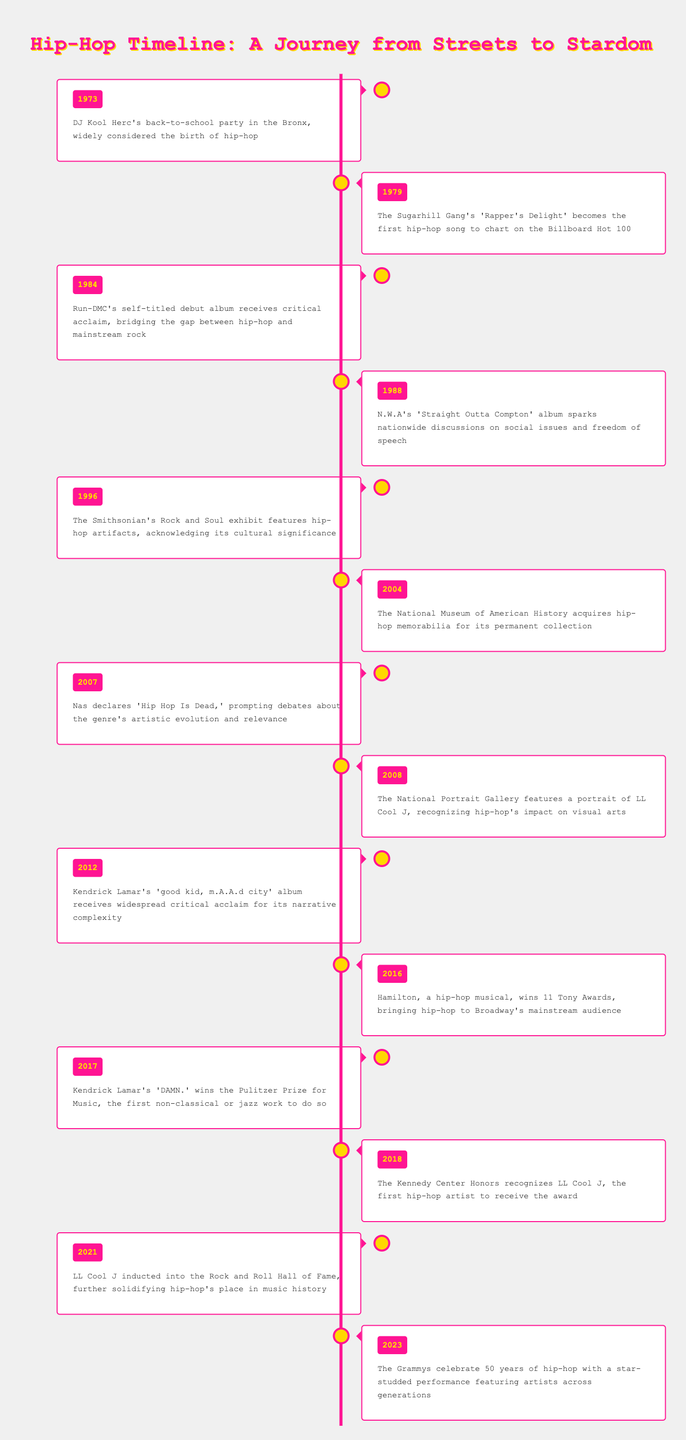What year is widely considered the birth of hip-hop? The table states that DJ Kool Herc's back-to-school party in the Bronx in 1973 is widely considered the birth of hip-hop.
Answer: 1973 Which hip-hop song first charted on the Billboard Hot 100? According to the table, The Sugarhill Gang's 'Rapper's Delight' in 1979 was the first hip-hop song to chart on the Billboard Hot 100.
Answer: 'Rapper's Delight' Was the Smithsonian's Rock and Soul exhibit a recognition of hip-hop? The table indicates that in 1996, the Smithsonian's Rock and Soul exhibit featured hip-hop artifacts, suggesting it acknowledged the cultural significance of hip-hop.
Answer: Yes How many years passed between the release of 'Rapper's Delight' and the first critical acclaim for Run-DMC's debut album? 'Rapper's Delight' was released in 1979 and Run-DMC's self-titled debut album received critical acclaim in 1984. The difference in years is 1984 - 1979 = 5 years.
Answer: 5 years What significant milestone occurred in the year 2017 for Kendrick Lamar? The table notes that in 2017, Kendrick Lamar's 'DAMN.' won the Pulitzer Prize for Music, marking a significant milestone as it was the first non-classical or jazz work to do so.
Answer: A Pulitzer Prize What year did the National Portrait Gallery feature a portrait of LL Cool J? The data reveals that the National Portrait Gallery featured a portrait of LL Cool J in 2008.
Answer: 2008 How many total key events relating to the recognition of hip-hop as an art form are listed in the table? The table outlines a total of 15 key events related to the recognition of hip-hop from 1973 to 2023.
Answer: 15 Which two events occurred in 2016 and 2023, respectively? In 2016, Hamilton, a hip-hop musical, won 11 Tony Awards, and in 2023, the Grammys celebrated 50 years of hip-hop. These events highlight hip-hop's acceptance in mainstream venues.
Answer: Hamilton's Tony Awards and 50th Grammys Was LL Cool J the first hip-hop artist to be inducted into the Rock and Roll Hall of Fame? The table confirms that LL Cool J was inducted into the Rock and Roll Hall of Fame in 2021, which suggests he was the first hip-hop artist recognized in this manner.
Answer: Yes 